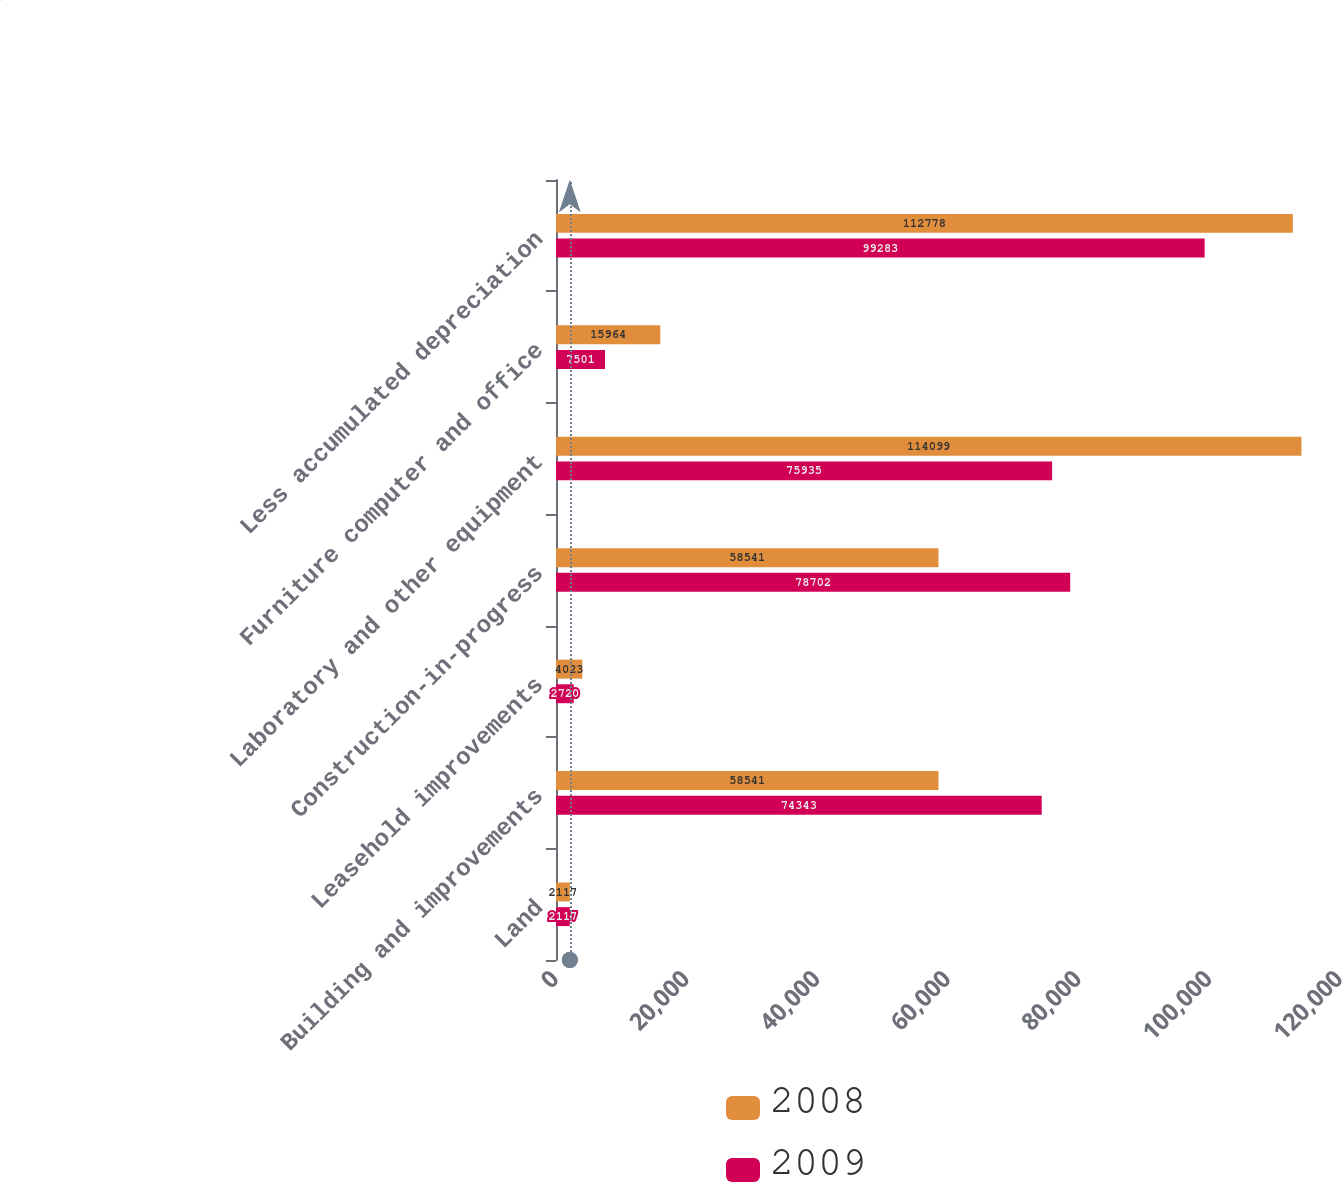<chart> <loc_0><loc_0><loc_500><loc_500><stacked_bar_chart><ecel><fcel>Land<fcel>Building and improvements<fcel>Leasehold improvements<fcel>Construction-in-progress<fcel>Laboratory and other equipment<fcel>Furniture computer and office<fcel>Less accumulated depreciation<nl><fcel>2008<fcel>2117<fcel>58541<fcel>4023<fcel>58541<fcel>114099<fcel>15964<fcel>112778<nl><fcel>2009<fcel>2117<fcel>74343<fcel>2720<fcel>78702<fcel>75935<fcel>7501<fcel>99283<nl></chart> 